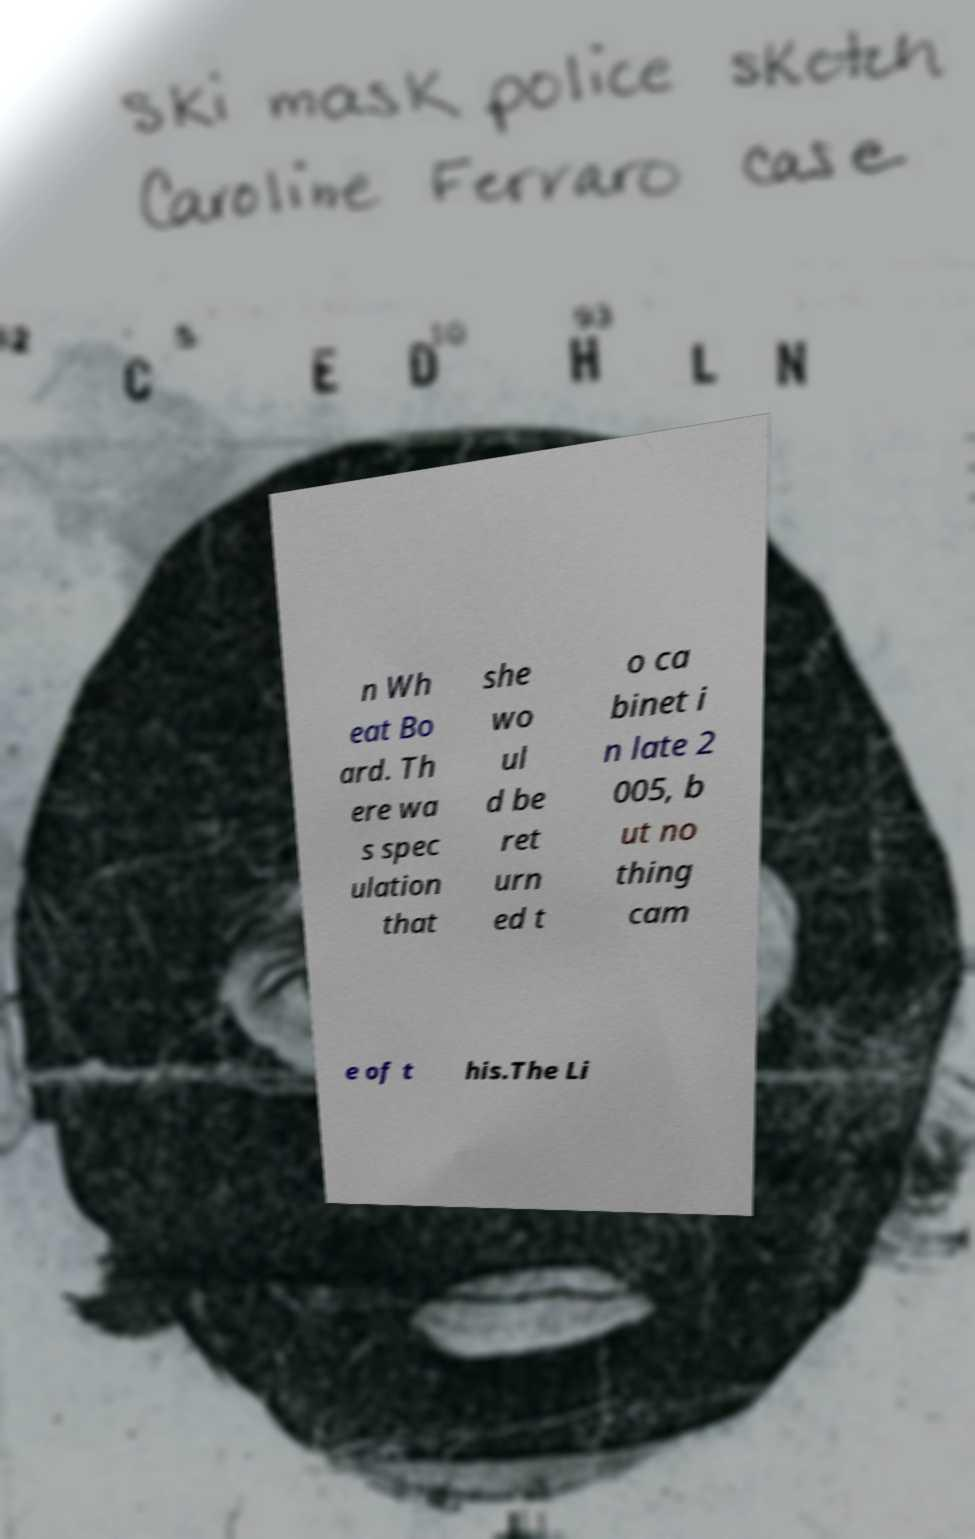What messages or text are displayed in this image? I need them in a readable, typed format. n Wh eat Bo ard. Th ere wa s spec ulation that she wo ul d be ret urn ed t o ca binet i n late 2 005, b ut no thing cam e of t his.The Li 